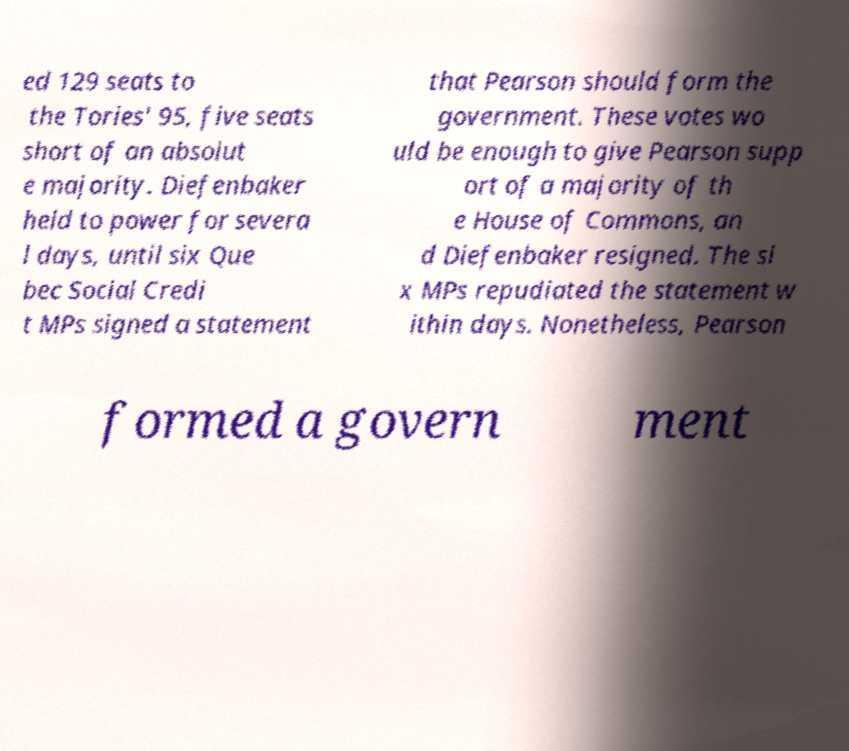Can you read and provide the text displayed in the image?This photo seems to have some interesting text. Can you extract and type it out for me? ed 129 seats to the Tories' 95, five seats short of an absolut e majority. Diefenbaker held to power for severa l days, until six Que bec Social Credi t MPs signed a statement that Pearson should form the government. These votes wo uld be enough to give Pearson supp ort of a majority of th e House of Commons, an d Diefenbaker resigned. The si x MPs repudiated the statement w ithin days. Nonetheless, Pearson formed a govern ment 